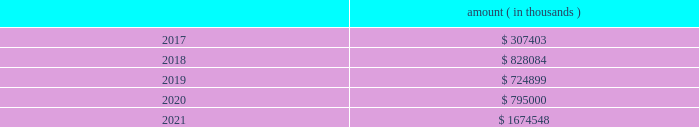Entergy corporation and subsidiaries notes to financial statements ( a ) consists of pollution control revenue bonds and environmental revenue bonds , some of which are secured by collateral first mortgage bonds .
( b ) these notes do not have a stated interest rate , but have an implicit interest rate of 4.8% ( 4.8 % ) .
( c ) pursuant to the nuclear waste policy act of 1982 , entergy 2019s nuclear owner/licensee subsidiaries have contracts with the doe for spent nuclear fuel disposal service .
The contracts include a one-time fee for generation prior to april 7 , 1983 .
Entergy arkansas is the only entergy company that generated electric power with nuclear fuel prior to that date and includes the one-time fee , plus accrued interest , in long-term debt .
( d ) see note 10 to the financial statements for further discussion of the waterford 3 lease obligation and entergy louisiana 2019s acquisition of the equity participant 2019s beneficial interest in the waterford 3 leased assets and for further discussion of the grand gulf lease obligation .
( e ) this note does not have a stated interest rate , but has an implicit interest rate of 7.458% ( 7.458 % ) .
( f ) the fair value excludes lease obligations of $ 57 million at entergy louisiana and $ 34 million at system energy , and long-term doe obligations of $ 182 million at entergy arkansas , and includes debt due within one year .
Fair values are classified as level 2 in the fair value hierarchy discussed in note 15 to the financial statements and are based on prices derived from inputs such as benchmark yields and reported trades .
The annual long-term debt maturities ( excluding lease obligations and long-term doe obligations ) for debt outstanding as of december 31 , 2016 , for the next five years are as follows : amount ( in thousands ) .
In november 2000 , entergy 2019s non-utility nuclear business purchased the fitzpatrick and indian point 3 power plants in a seller-financed transaction .
As part of the purchase agreement with nypa , entergy recorded a liability representing the net present value of the payments entergy would be liable to nypa for each year that the fitzpatrick and indian point 3 power plants would run beyond their respective original nrc license expiration date .
In october 2015 , entergy announced a planned shutdown of fitzpatrick at the end of its fuel cycle .
As a result of the announcement , entergy reduced this liability by $ 26.4 million pursuant to the terms of the purchase agreement .
In august 2016 , entergy entered into a trust transfer agreement with nypa to transfer the decommissioning trust funds and decommissioning liabilities for the indian point 3 and fitzpatrick plants to entergy .
As part of the trust transfer agreement , the original decommissioning agreements were amended , and the entergy subsidiaries 2019 obligation to make additional license extension payments to nypa was eliminated .
In the third quarter 2016 , entergy removed the note payable of $ 35.1 million from the consolidated balance sheet .
Entergy louisiana , entergy mississippi , entergy texas , and system energy have obtained long-term financing authorizations from the ferc that extend through october 2017 .
Entergy arkansas has obtained long-term financing authorization from the apsc that extends through december 2018 .
Entergy new orleans has obtained long-term financing authorization from the city council that extends through june 2018 .
Capital funds agreement pursuant to an agreement with certain creditors , entergy corporation has agreed to supply system energy with sufficient capital to : 2022 maintain system energy 2019s equity capital at a minimum of 35% ( 35 % ) of its total capitalization ( excluding short- term debt ) ; .
What amount of long-term debt is due in the next 24 months for entergy corporation as of december 31 , 2016 , in millions? 
Computations: ((307403 + 828084) / 1000)
Answer: 1135.487. 